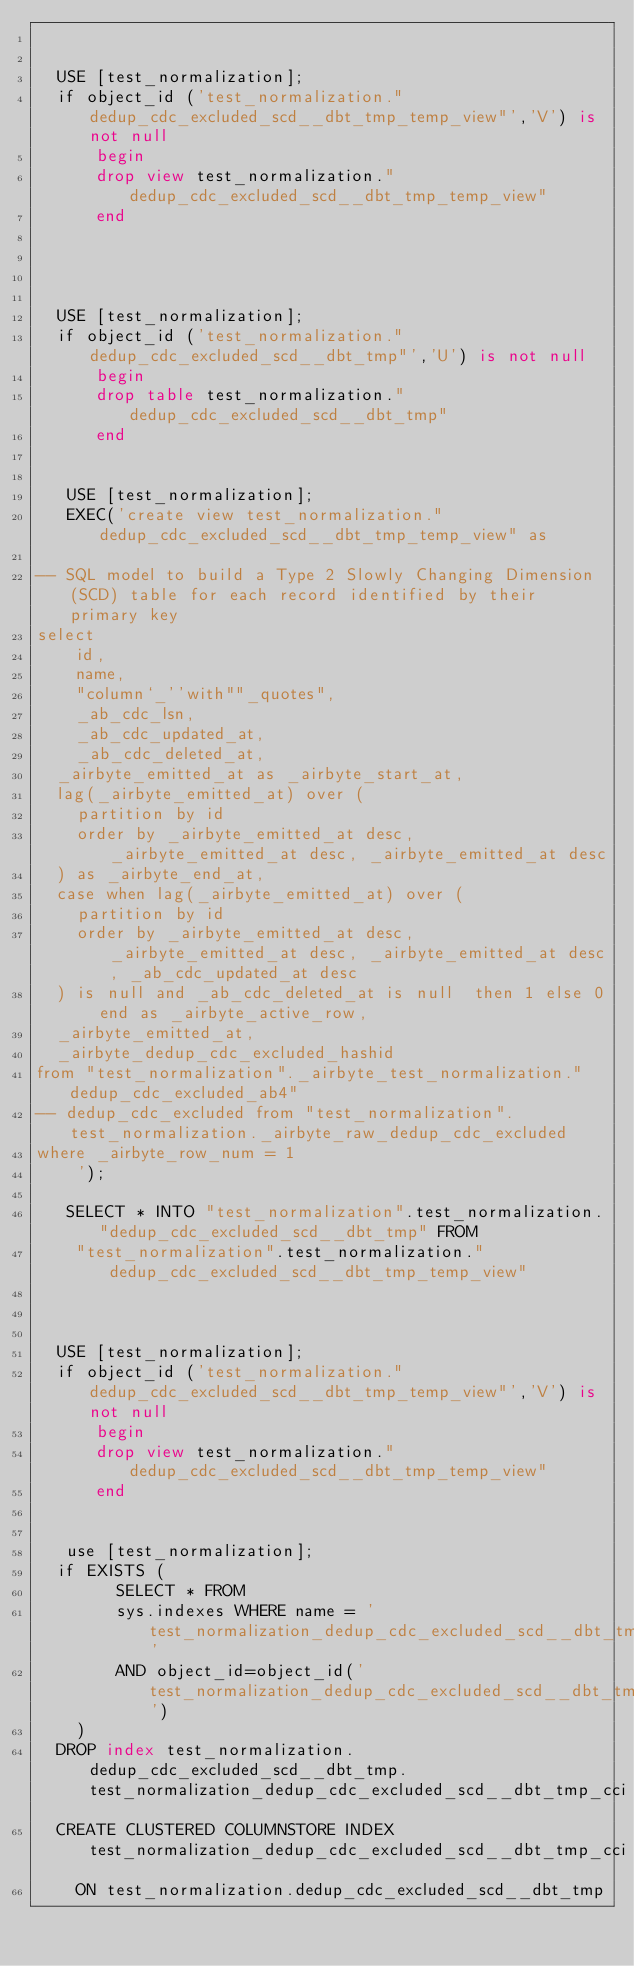Convert code to text. <code><loc_0><loc_0><loc_500><loc_500><_SQL_>
   
  USE [test_normalization];
  if object_id ('test_normalization."dedup_cdc_excluded_scd__dbt_tmp_temp_view"','V') is not null
      begin
      drop view test_normalization."dedup_cdc_excluded_scd__dbt_tmp_temp_view"
      end


   
   
  USE [test_normalization];
  if object_id ('test_normalization."dedup_cdc_excluded_scd__dbt_tmp"','U') is not null
      begin
      drop table test_normalization."dedup_cdc_excluded_scd__dbt_tmp"
      end


   USE [test_normalization];
   EXEC('create view test_normalization."dedup_cdc_excluded_scd__dbt_tmp_temp_view" as
    
-- SQL model to build a Type 2 Slowly Changing Dimension (SCD) table for each record identified by their primary key
select
    id,
    name,
    "column`_''with""_quotes",
    _ab_cdc_lsn,
    _ab_cdc_updated_at,
    _ab_cdc_deleted_at,
  _airbyte_emitted_at as _airbyte_start_at,
  lag(_airbyte_emitted_at) over (
    partition by id
    order by _airbyte_emitted_at desc, _airbyte_emitted_at desc, _airbyte_emitted_at desc
  ) as _airbyte_end_at,
  case when lag(_airbyte_emitted_at) over (
    partition by id
    order by _airbyte_emitted_at desc, _airbyte_emitted_at desc, _airbyte_emitted_at desc, _ab_cdc_updated_at desc
  ) is null and _ab_cdc_deleted_at is null  then 1 else 0 end as _airbyte_active_row,
  _airbyte_emitted_at,
  _airbyte_dedup_cdc_excluded_hashid
from "test_normalization"._airbyte_test_normalization."dedup_cdc_excluded_ab4"
-- dedup_cdc_excluded from "test_normalization".test_normalization._airbyte_raw_dedup_cdc_excluded
where _airbyte_row_num = 1
    ');

   SELECT * INTO "test_normalization".test_normalization."dedup_cdc_excluded_scd__dbt_tmp" FROM
    "test_normalization".test_normalization."dedup_cdc_excluded_scd__dbt_tmp_temp_view"

   
   
  USE [test_normalization];
  if object_id ('test_normalization."dedup_cdc_excluded_scd__dbt_tmp_temp_view"','V') is not null
      begin
      drop view test_normalization."dedup_cdc_excluded_scd__dbt_tmp_temp_view"
      end

    
   use [test_normalization];
  if EXISTS (
        SELECT * FROM
        sys.indexes WHERE name = 'test_normalization_dedup_cdc_excluded_scd__dbt_tmp_cci'
        AND object_id=object_id('test_normalization_dedup_cdc_excluded_scd__dbt_tmp')
    )
  DROP index test_normalization.dedup_cdc_excluded_scd__dbt_tmp.test_normalization_dedup_cdc_excluded_scd__dbt_tmp_cci
  CREATE CLUSTERED COLUMNSTORE INDEX test_normalization_dedup_cdc_excluded_scd__dbt_tmp_cci
    ON test_normalization.dedup_cdc_excluded_scd__dbt_tmp

   

</code> 